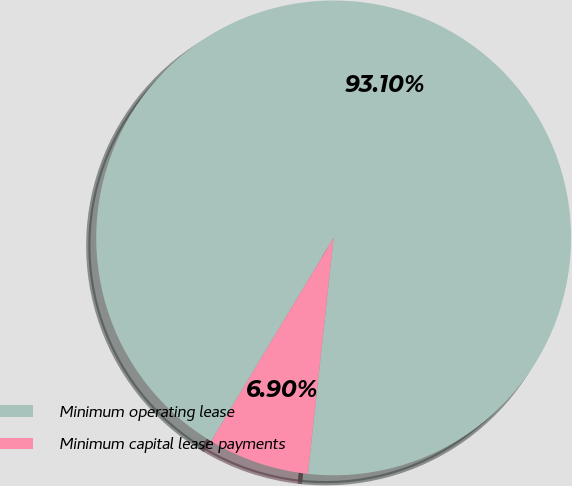<chart> <loc_0><loc_0><loc_500><loc_500><pie_chart><fcel>Minimum operating lease<fcel>Minimum capital lease payments<nl><fcel>93.1%<fcel>6.9%<nl></chart> 